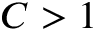<formula> <loc_0><loc_0><loc_500><loc_500>C > 1</formula> 